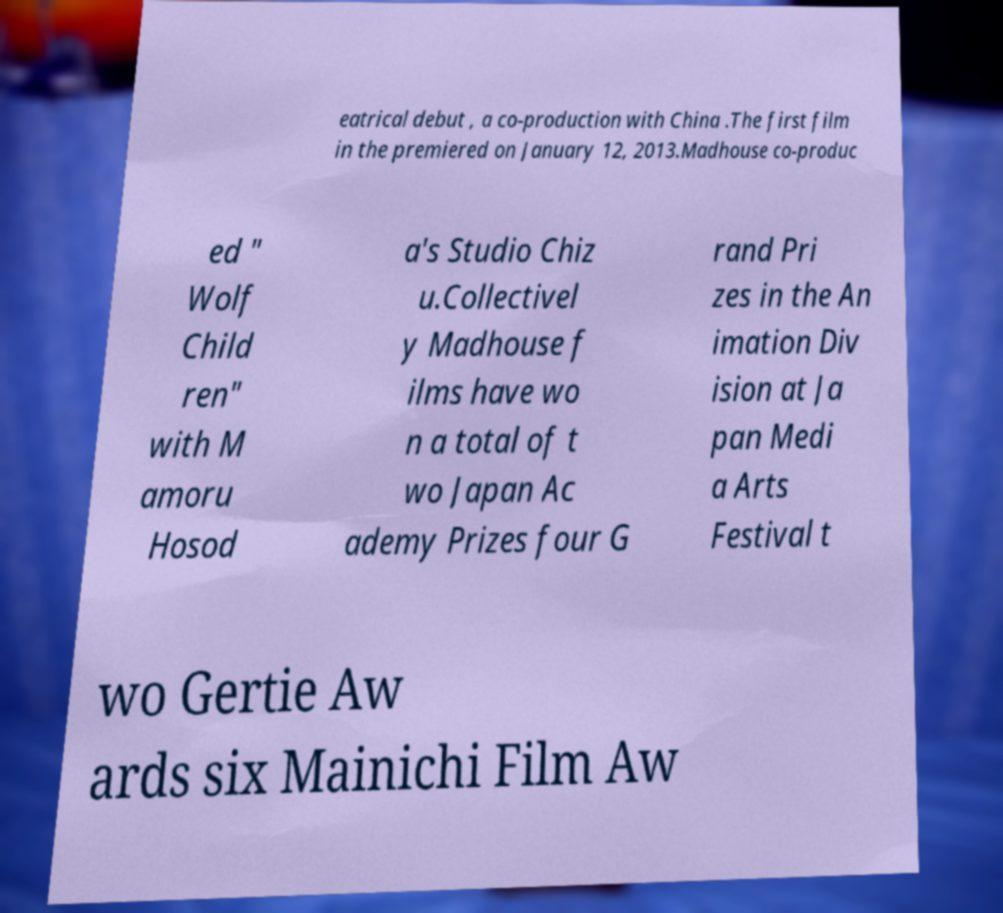For documentation purposes, I need the text within this image transcribed. Could you provide that? eatrical debut , a co-production with China .The first film in the premiered on January 12, 2013.Madhouse co-produc ed " Wolf Child ren" with M amoru Hosod a's Studio Chiz u.Collectivel y Madhouse f ilms have wo n a total of t wo Japan Ac ademy Prizes four G rand Pri zes in the An imation Div ision at Ja pan Medi a Arts Festival t wo Gertie Aw ards six Mainichi Film Aw 